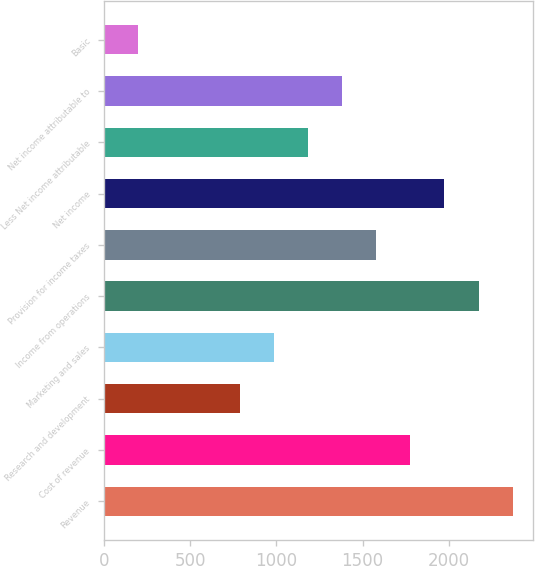<chart> <loc_0><loc_0><loc_500><loc_500><bar_chart><fcel>Revenue<fcel>Cost of revenue<fcel>Research and development<fcel>Marketing and sales<fcel>Income from operations<fcel>Provision for income taxes<fcel>Net income<fcel>Less Net income attributable<fcel>Net income attributable to<fcel>Basic<nl><fcel>2368.72<fcel>1776.61<fcel>789.76<fcel>987.13<fcel>2171.35<fcel>1579.24<fcel>1973.98<fcel>1184.5<fcel>1381.87<fcel>197.65<nl></chart> 